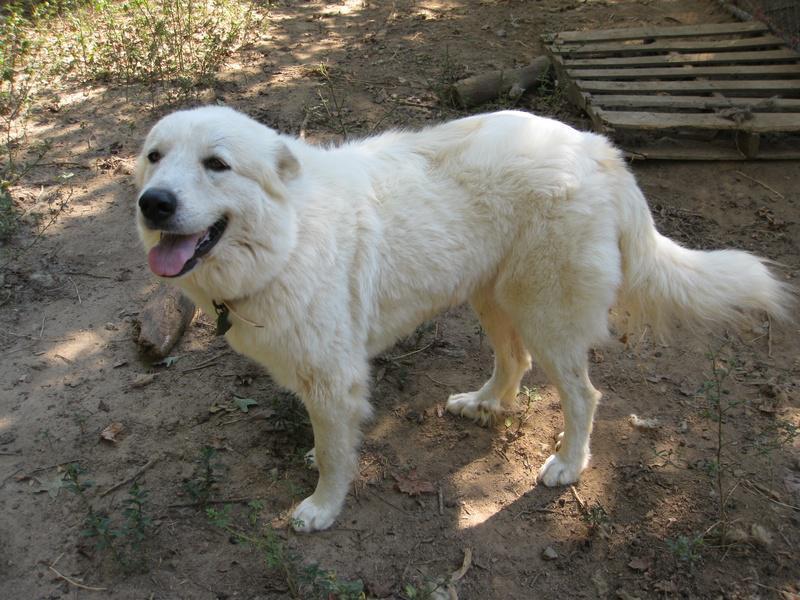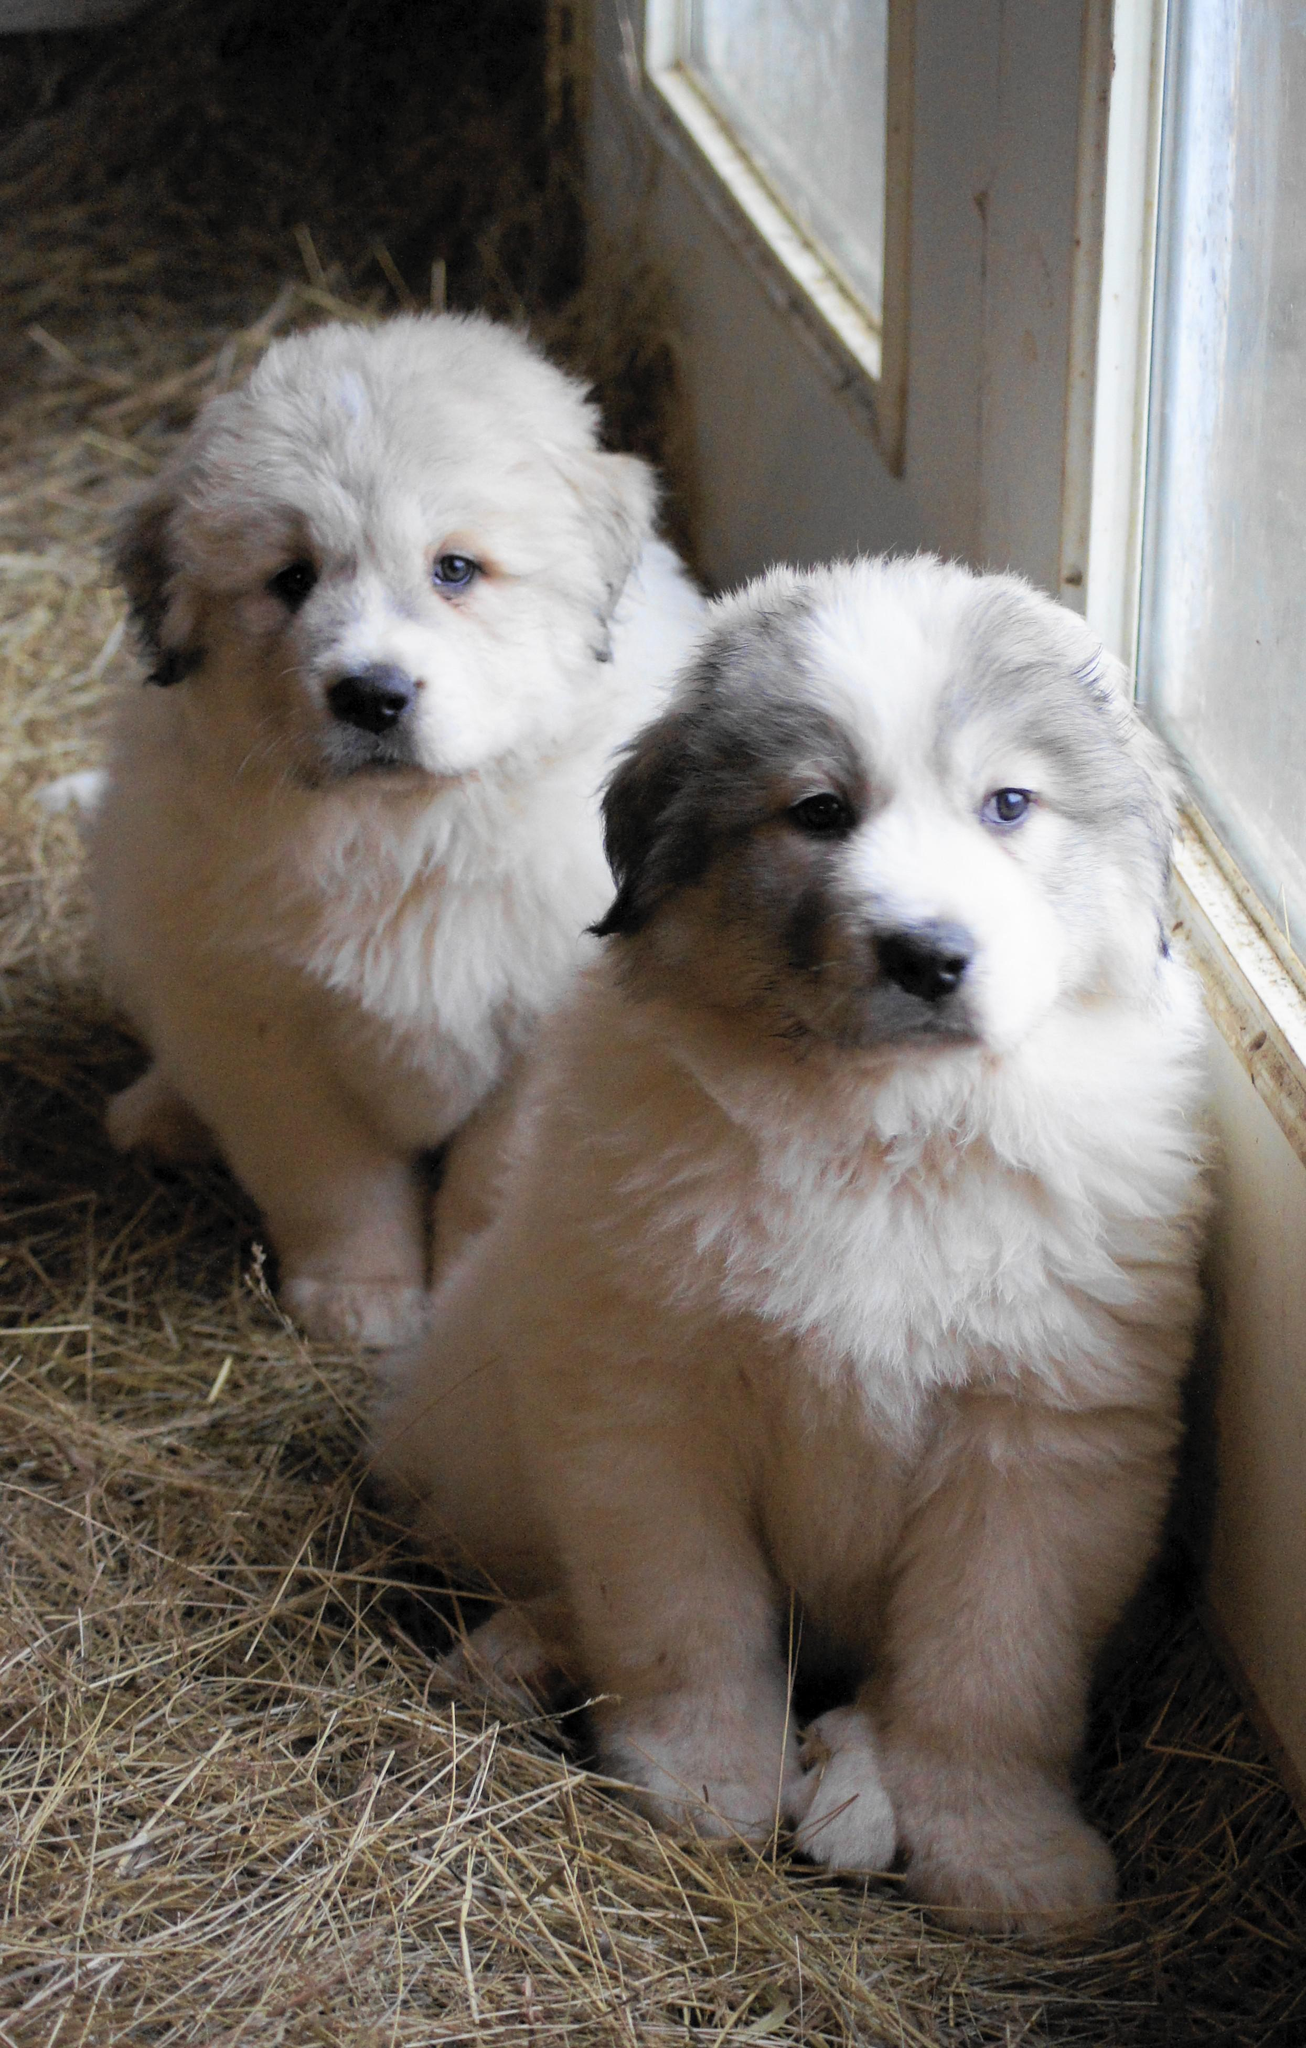The first image is the image on the left, the second image is the image on the right. Considering the images on both sides, is "the right pic has two or more dogs" valid? Answer yes or no. Yes. The first image is the image on the left, the second image is the image on the right. Evaluate the accuracy of this statement regarding the images: "In at least one image there are exactly two dogs that are seated close together.". Is it true? Answer yes or no. Yes. 